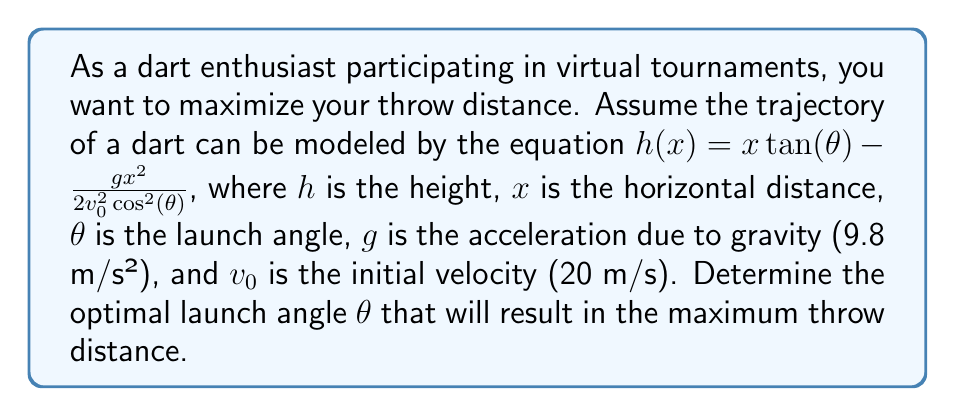What is the answer to this math problem? To find the optimal launch angle for maximum throw distance, we need to follow these steps:

1) The maximum distance occurs when the dart hits the ground, i.e., when $h(x) = 0$. So we solve:

   $0 = x \tan(\theta) - \frac{gx^2}{2v_0^2\cos^2(\theta)}$

2) Factor out $x$:

   $x(tan(\theta) - \frac{gx}{2v_0^2\cos^2(\theta)}) = 0$

3) The non-zero solution gives us the distance:

   $x = \frac{2v_0^2}{g} \sin(\theta)\cos(\theta) = \frac{v_0^2}{g} \sin(2\theta)$

4) To maximize this, we need to maximize $\sin(2\theta)$. The maximum value of sine is 1, which occurs when its argument is 90°.

5) So, $2\theta = 90°$, or $\theta = 45°$

6) To verify this is indeed a maximum, we can use the second derivative test:

   $\frac{d}{d\theta}(\sin(2\theta)) = 2\cos(2\theta)$
   $\frac{d^2}{d\theta^2}(\sin(2\theta)) = -4\sin(2\theta)$

   At $\theta = 45°$, the second derivative is negative, confirming a maximum.

Therefore, the optimal launch angle for maximum throw distance is 45°.
Answer: $45°$ 